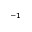<formula> <loc_0><loc_0><loc_500><loc_500>^ { - 1 }</formula> 